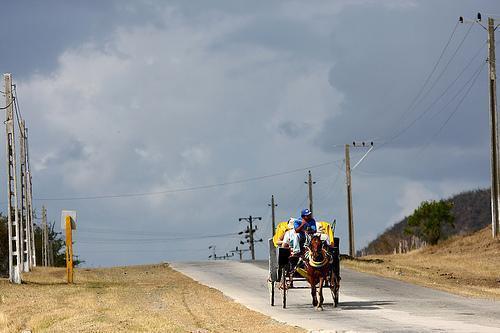How many people are pictured?
Give a very brief answer. 1. 